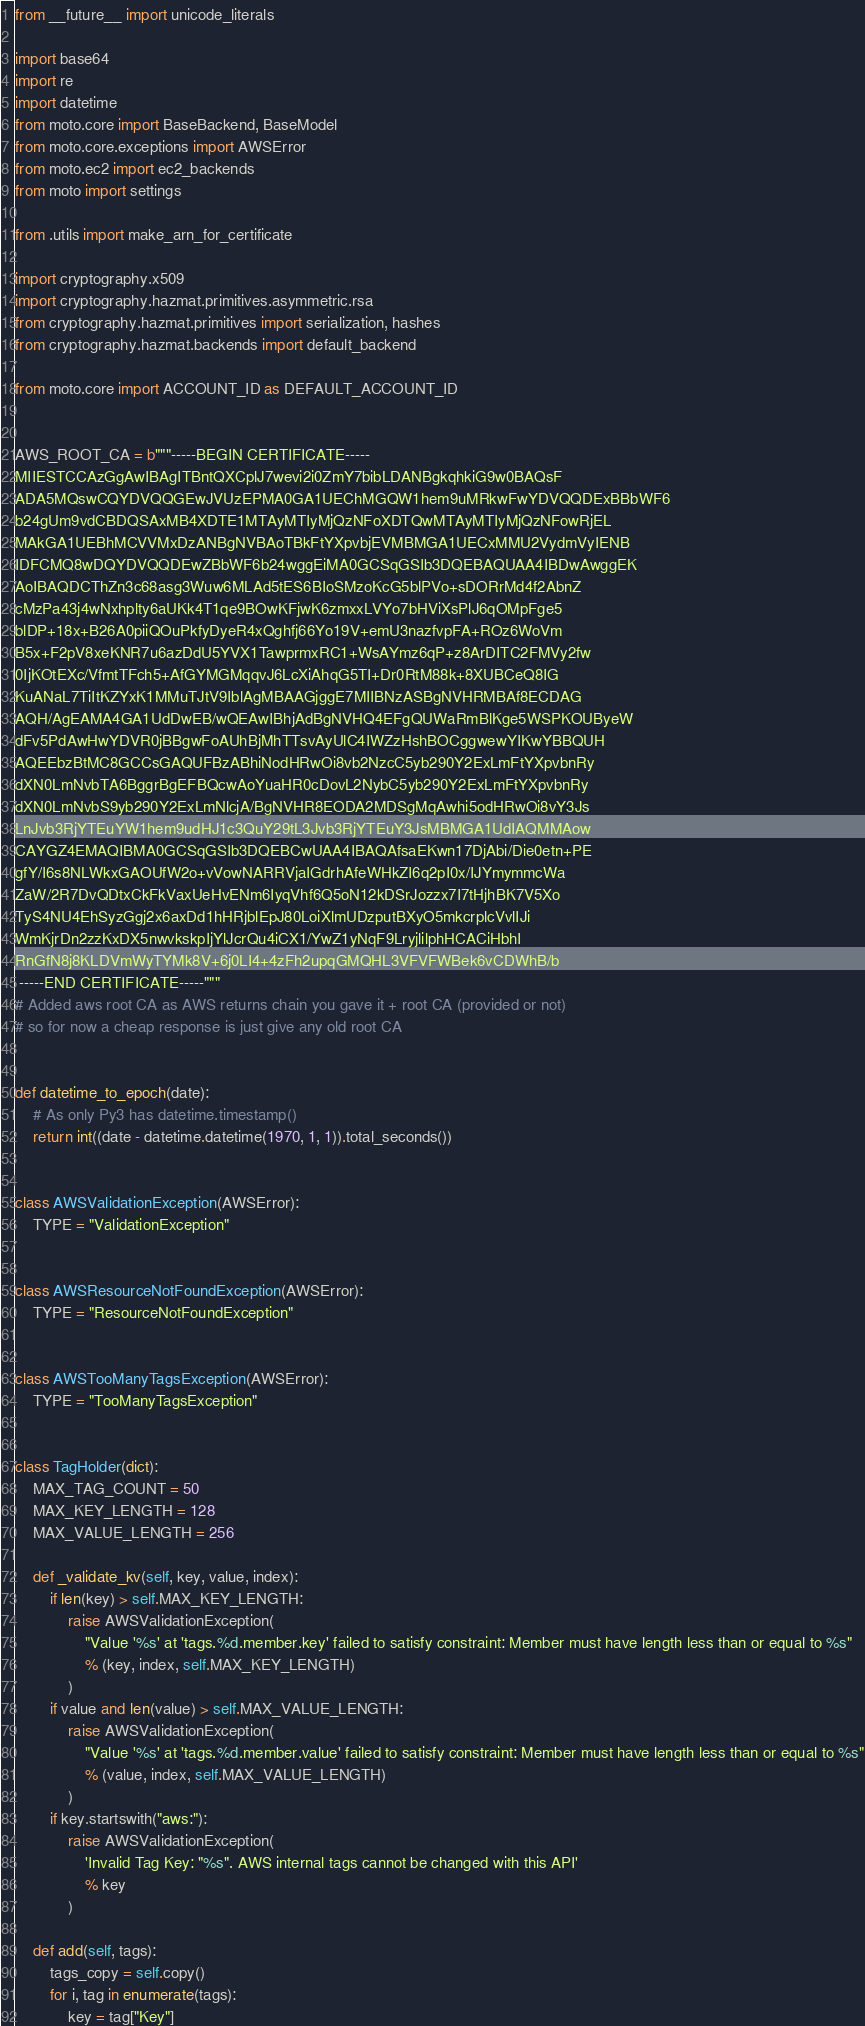<code> <loc_0><loc_0><loc_500><loc_500><_Python_>from __future__ import unicode_literals

import base64
import re
import datetime
from moto.core import BaseBackend, BaseModel
from moto.core.exceptions import AWSError
from moto.ec2 import ec2_backends
from moto import settings

from .utils import make_arn_for_certificate

import cryptography.x509
import cryptography.hazmat.primitives.asymmetric.rsa
from cryptography.hazmat.primitives import serialization, hashes
from cryptography.hazmat.backends import default_backend

from moto.core import ACCOUNT_ID as DEFAULT_ACCOUNT_ID


AWS_ROOT_CA = b"""-----BEGIN CERTIFICATE-----
MIIESTCCAzGgAwIBAgITBntQXCplJ7wevi2i0ZmY7bibLDANBgkqhkiG9w0BAQsF
ADA5MQswCQYDVQQGEwJVUzEPMA0GA1UEChMGQW1hem9uMRkwFwYDVQQDExBBbWF6
b24gUm9vdCBDQSAxMB4XDTE1MTAyMTIyMjQzNFoXDTQwMTAyMTIyMjQzNFowRjEL
MAkGA1UEBhMCVVMxDzANBgNVBAoTBkFtYXpvbjEVMBMGA1UECxMMU2VydmVyIENB
IDFCMQ8wDQYDVQQDEwZBbWF6b24wggEiMA0GCSqGSIb3DQEBAQUAA4IBDwAwggEK
AoIBAQDCThZn3c68asg3Wuw6MLAd5tES6BIoSMzoKcG5blPVo+sDORrMd4f2AbnZ
cMzPa43j4wNxhplty6aUKk4T1qe9BOwKFjwK6zmxxLVYo7bHViXsPlJ6qOMpFge5
blDP+18x+B26A0piiQOuPkfyDyeR4xQghfj66Yo19V+emU3nazfvpFA+ROz6WoVm
B5x+F2pV8xeKNR7u6azDdU5YVX1TawprmxRC1+WsAYmz6qP+z8ArDITC2FMVy2fw
0IjKOtEXc/VfmtTFch5+AfGYMGMqqvJ6LcXiAhqG5TI+Dr0RtM88k+8XUBCeQ8IG
KuANaL7TiItKZYxK1MMuTJtV9IblAgMBAAGjggE7MIIBNzASBgNVHRMBAf8ECDAG
AQH/AgEAMA4GA1UdDwEB/wQEAwIBhjAdBgNVHQ4EFgQUWaRmBlKge5WSPKOUByeW
dFv5PdAwHwYDVR0jBBgwFoAUhBjMhTTsvAyUlC4IWZzHshBOCggwewYIKwYBBQUH
AQEEbzBtMC8GCCsGAQUFBzABhiNodHRwOi8vb2NzcC5yb290Y2ExLmFtYXpvbnRy
dXN0LmNvbTA6BggrBgEFBQcwAoYuaHR0cDovL2NybC5yb290Y2ExLmFtYXpvbnRy
dXN0LmNvbS9yb290Y2ExLmNlcjA/BgNVHR8EODA2MDSgMqAwhi5odHRwOi8vY3Js
LnJvb3RjYTEuYW1hem9udHJ1c3QuY29tL3Jvb3RjYTEuY3JsMBMGA1UdIAQMMAow
CAYGZ4EMAQIBMA0GCSqGSIb3DQEBCwUAA4IBAQAfsaEKwn17DjAbi/Die0etn+PE
gfY/I6s8NLWkxGAOUfW2o+vVowNARRVjaIGdrhAfeWHkZI6q2pI0x/IJYmymmcWa
ZaW/2R7DvQDtxCkFkVaxUeHvENm6IyqVhf6Q5oN12kDSrJozzx7I7tHjhBK7V5Xo
TyS4NU4EhSyzGgj2x6axDd1hHRjblEpJ80LoiXlmUDzputBXyO5mkcrplcVvlIJi
WmKjrDn2zzKxDX5nwvkskpIjYlJcrQu4iCX1/YwZ1yNqF9LryjlilphHCACiHbhI
RnGfN8j8KLDVmWyTYMk8V+6j0LI4+4zFh2upqGMQHL3VFVFWBek6vCDWhB/b
 -----END CERTIFICATE-----"""
# Added aws root CA as AWS returns chain you gave it + root CA (provided or not)
# so for now a cheap response is just give any old root CA


def datetime_to_epoch(date):
    # As only Py3 has datetime.timestamp()
    return int((date - datetime.datetime(1970, 1, 1)).total_seconds())


class AWSValidationException(AWSError):
    TYPE = "ValidationException"


class AWSResourceNotFoundException(AWSError):
    TYPE = "ResourceNotFoundException"


class AWSTooManyTagsException(AWSError):
    TYPE = "TooManyTagsException"


class TagHolder(dict):
    MAX_TAG_COUNT = 50
    MAX_KEY_LENGTH = 128
    MAX_VALUE_LENGTH = 256

    def _validate_kv(self, key, value, index):
        if len(key) > self.MAX_KEY_LENGTH:
            raise AWSValidationException(
                "Value '%s' at 'tags.%d.member.key' failed to satisfy constraint: Member must have length less than or equal to %s"
                % (key, index, self.MAX_KEY_LENGTH)
            )
        if value and len(value) > self.MAX_VALUE_LENGTH:
            raise AWSValidationException(
                "Value '%s' at 'tags.%d.member.value' failed to satisfy constraint: Member must have length less than or equal to %s"
                % (value, index, self.MAX_VALUE_LENGTH)
            )
        if key.startswith("aws:"):
            raise AWSValidationException(
                'Invalid Tag Key: "%s". AWS internal tags cannot be changed with this API'
                % key
            )

    def add(self, tags):
        tags_copy = self.copy()
        for i, tag in enumerate(tags):
            key = tag["Key"]</code> 